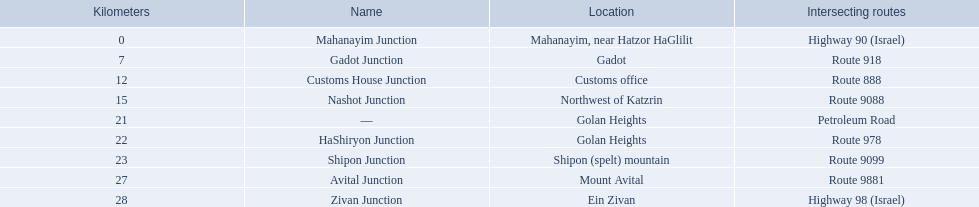Which intersecting routes are route 918 Route 918. What is the name? Gadot Junction. What are the various locations along highway 91 (israel)? Mahanayim, near Hatzor HaGlilit, Gadot, Customs office, Northwest of Katzrin, Golan Heights, Golan Heights, Shipon (spelt) mountain, Mount Avital, Ein Zivan. What are the distance measurements in kilometers for ein zivan, gadot junction, and shipon junction? 7, 23, 28. Which location has the shortest distance? 7. What is its name? Gadot Junction. How far is shipon junction in kilometers? 23. How far is avital junction in kilometers? 27. Between shipon and avital junctions, which is closer to nashot junction? Shipon Junction. 